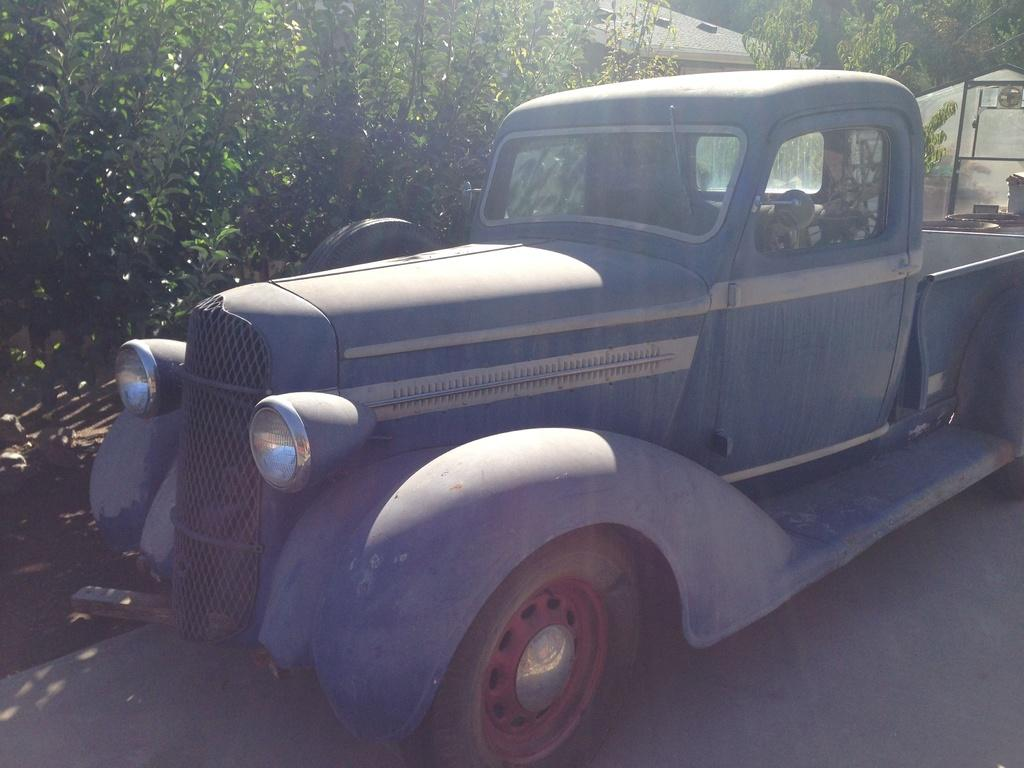What is the main subject of the image? There is a vehicle in the image. How is the vehicle depicted in the image? The vehicle is truncated. What else can be seen in the image besides the vehicle? There are objects and trees in the image. How are the objects and trees depicted in the image? The objects and trees are truncated towards the right of the image. What else is present in the image? There is a roof in the image. How is the roof depicted in the image? The roof is truncated. What type of voyage is the vehicle embarking on in the image? There is no indication of a voyage in the image, as it only shows a truncated vehicle and other truncated elements. What type of historical event is depicted in the image? There is no historical event depicted in the image; it only shows a truncated vehicle and other truncated elements. 